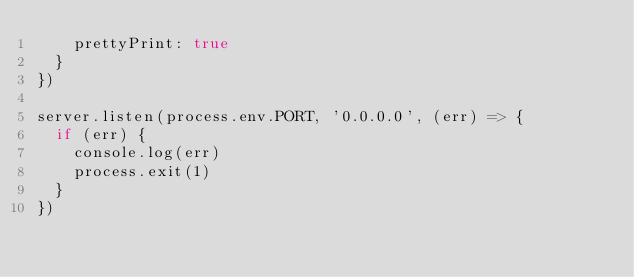Convert code to text. <code><loc_0><loc_0><loc_500><loc_500><_JavaScript_>    prettyPrint: true
  }
})

server.listen(process.env.PORT, '0.0.0.0', (err) => {
  if (err) {
    console.log(err)
    process.exit(1)
  }
})
</code> 